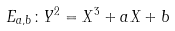Convert formula to latex. <formula><loc_0><loc_0><loc_500><loc_500>E _ { a , b } \colon Y ^ { 2 } = X ^ { 3 } + a X + b</formula> 